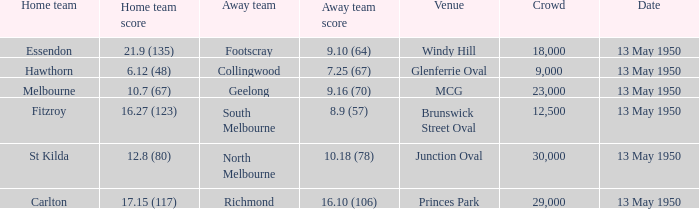What was the lowest crowd size at the Windy Hill venue? 18000.0. 